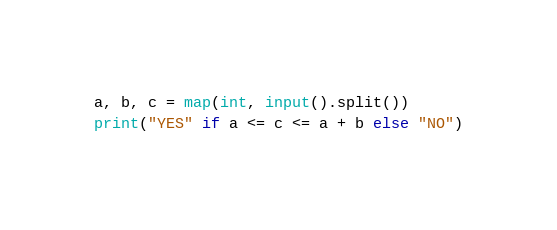Convert code to text. <code><loc_0><loc_0><loc_500><loc_500><_Python_>a, b, c = map(int, input().split())
print("YES" if a <= c <= a + b else "NO")</code> 